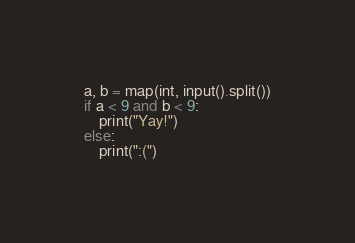Convert code to text. <code><loc_0><loc_0><loc_500><loc_500><_Python_>a, b = map(int, input().split())
if a < 9 and b < 9:
    print("Yay!")
else:
    print(":(")</code> 